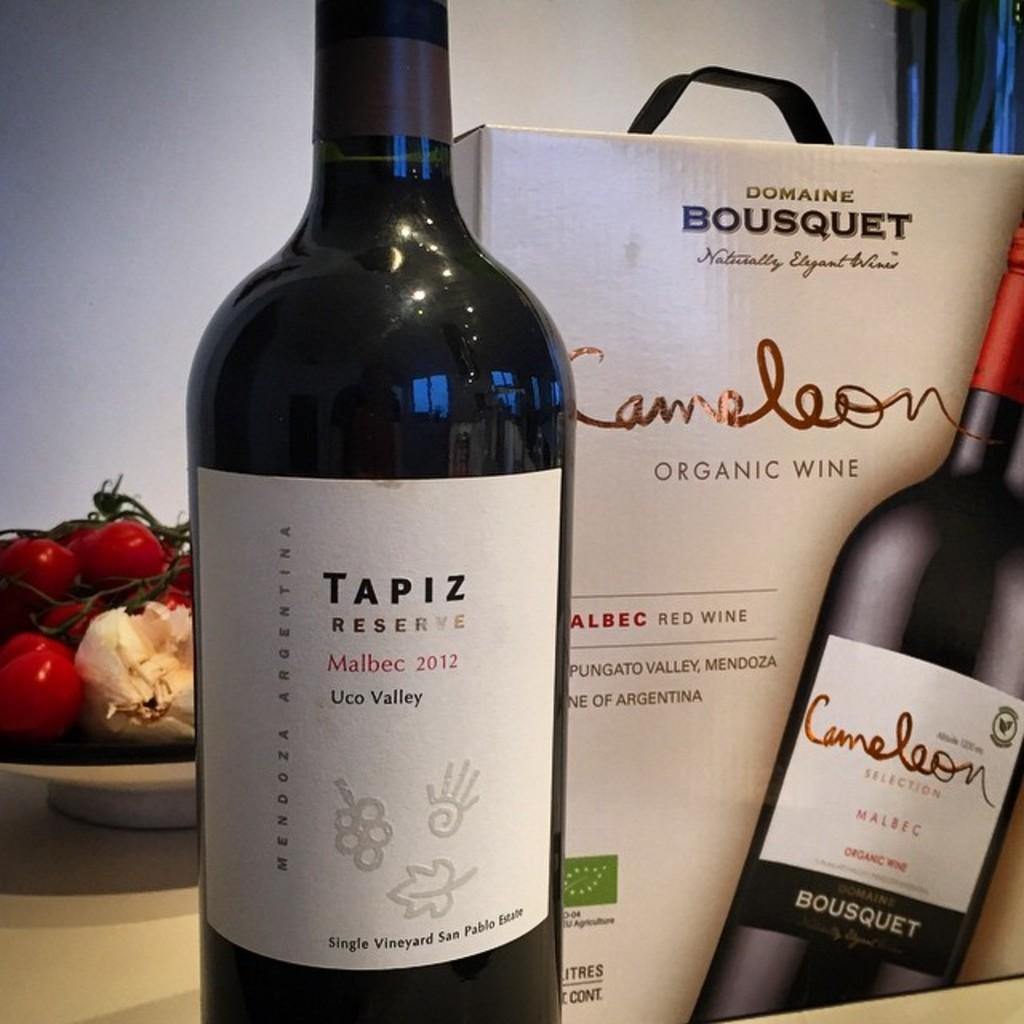<image>
Write a terse but informative summary of the picture. A bottle of Tapiz Reserve and the box that it came in. 